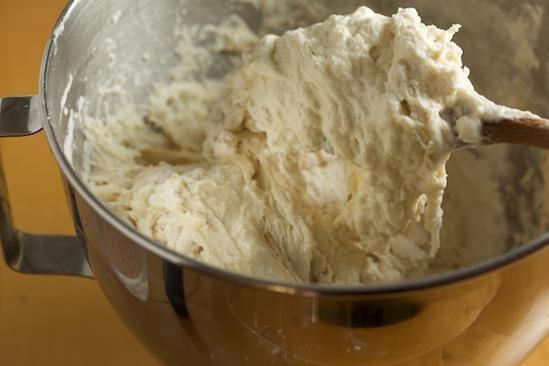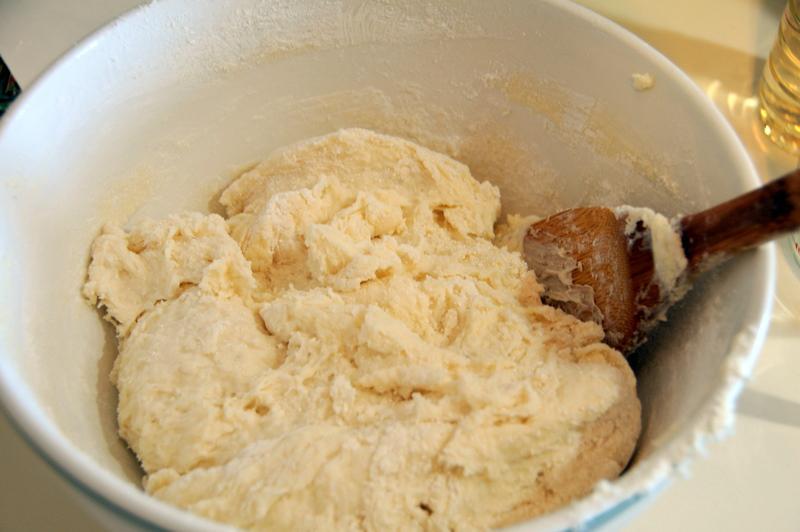The first image is the image on the left, the second image is the image on the right. Analyze the images presented: Is the assertion "In one of the images, the dough is being stirred by a mixer." valid? Answer yes or no. No. The first image is the image on the left, the second image is the image on the right. Examine the images to the left and right. Is the description "Only one wooden spoon is visible." accurate? Answer yes or no. No. 